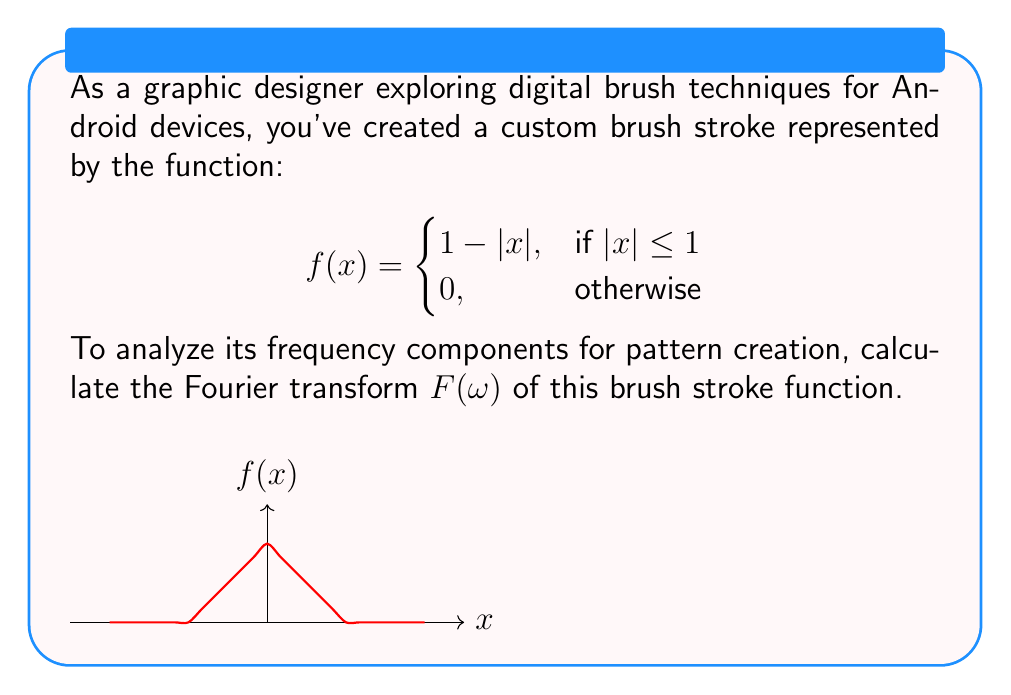Help me with this question. To find the Fourier transform, we use the definition:

$$F(\omega) = \int_{-\infty}^{\infty} f(x) e^{-i\omega x} dx$$

For our piecewise function, we can split the integral:

$$F(\omega) = \int_{-1}^{0} (1+x) e^{-i\omega x} dx + \int_{0}^{1} (1-x) e^{-i\omega x} dx$$

Step 1: Evaluate the first integral
$$\int_{-1}^{0} (1+x) e^{-i\omega x} dx = \left[-\frac{1}{i\omega}(1+x)e^{-i\omega x}\right]_{-1}^{0} + \frac{1}{i\omega}\int_{-1}^{0} e^{-i\omega x} dx$$
$$= -\frac{1}{i\omega} + \frac{1}{i\omega}\left[-\frac{1}{i\omega}e^{-i\omega x}\right]_{-1}^{0} = -\frac{1}{i\omega} + \frac{1}{(i\omega)^2}(1-e^{i\omega})$$

Step 2: Evaluate the second integral (similar process)
$$\int_{0}^{1} (1-x) e^{-i\omega x} dx = -\frac{1}{i\omega} + \frac{1}{(i\omega)^2}(e^{-i\omega}-1)$$

Step 3: Sum the results
$$F(\omega) = -\frac{2}{i\omega} + \frac{1}{(i\omega)^2}(1-e^{i\omega}) + \frac{1}{(i\omega)^2}(e^{-i\omega}-1)$$

Step 4: Simplify
$$F(\omega) = -\frac{2}{i\omega} + \frac{1}{(i\omega)^2}(1-e^{i\omega}+e^{-i\omega}-1)$$
$$= -\frac{2}{i\omega} + \frac{2}{(i\omega)^2}(\cos(\omega)-1)$$

Step 5: Use Euler's formula $\cos(\omega) = \frac{e^{i\omega}+e^{-i\omega}}{2}$
$$F(\omega) = -\frac{2}{i\omega} + \frac{1}{(i\omega)^2}(e^{i\omega}+e^{-i\omega}-2)$$

Step 6: Factor out $\frac{2}{\omega^2}$
$$F(\omega) = \frac{2}{\omega^2}\left(1-\cos(\omega)\right)$$
Answer: $$F(\omega) = \frac{2}{\omega^2}\left(1-\cos(\omega)\right)$$ 